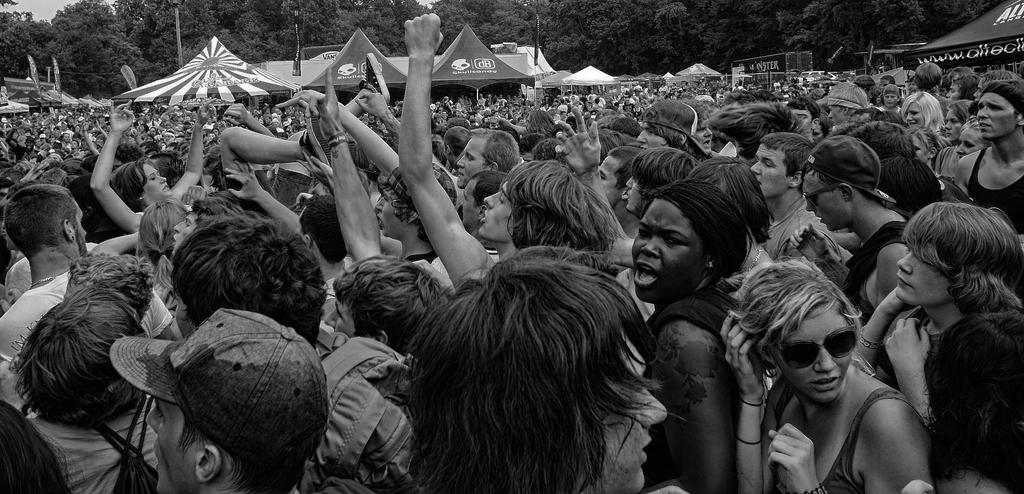What is the color scheme of the image? The image is black and white. Where are the people located in the image? The people are in the center of the image. What can be seen in the background of the image? There are trees and tents in the background of the image. What type of glass is being used by the laborer in the image? There is no laborer or glass present in the image. How many muscles can be seen on the people in the image? The image is black and white, and it is not possible to determine the number of muscles on the people in the image. 